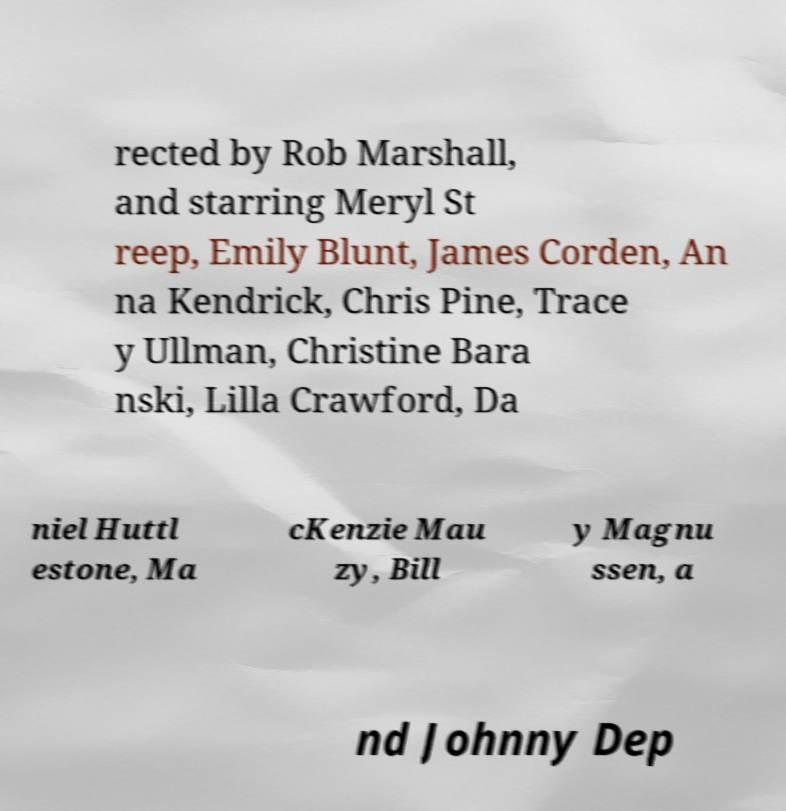Can you accurately transcribe the text from the provided image for me? rected by Rob Marshall, and starring Meryl St reep, Emily Blunt, James Corden, An na Kendrick, Chris Pine, Trace y Ullman, Christine Bara nski, Lilla Crawford, Da niel Huttl estone, Ma cKenzie Mau zy, Bill y Magnu ssen, a nd Johnny Dep 